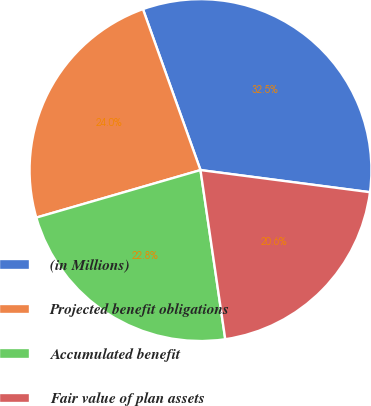Convert chart to OTSL. <chart><loc_0><loc_0><loc_500><loc_500><pie_chart><fcel>(in Millions)<fcel>Projected benefit obligations<fcel>Accumulated benefit<fcel>Fair value of plan assets<nl><fcel>32.53%<fcel>24.02%<fcel>22.83%<fcel>20.62%<nl></chart> 